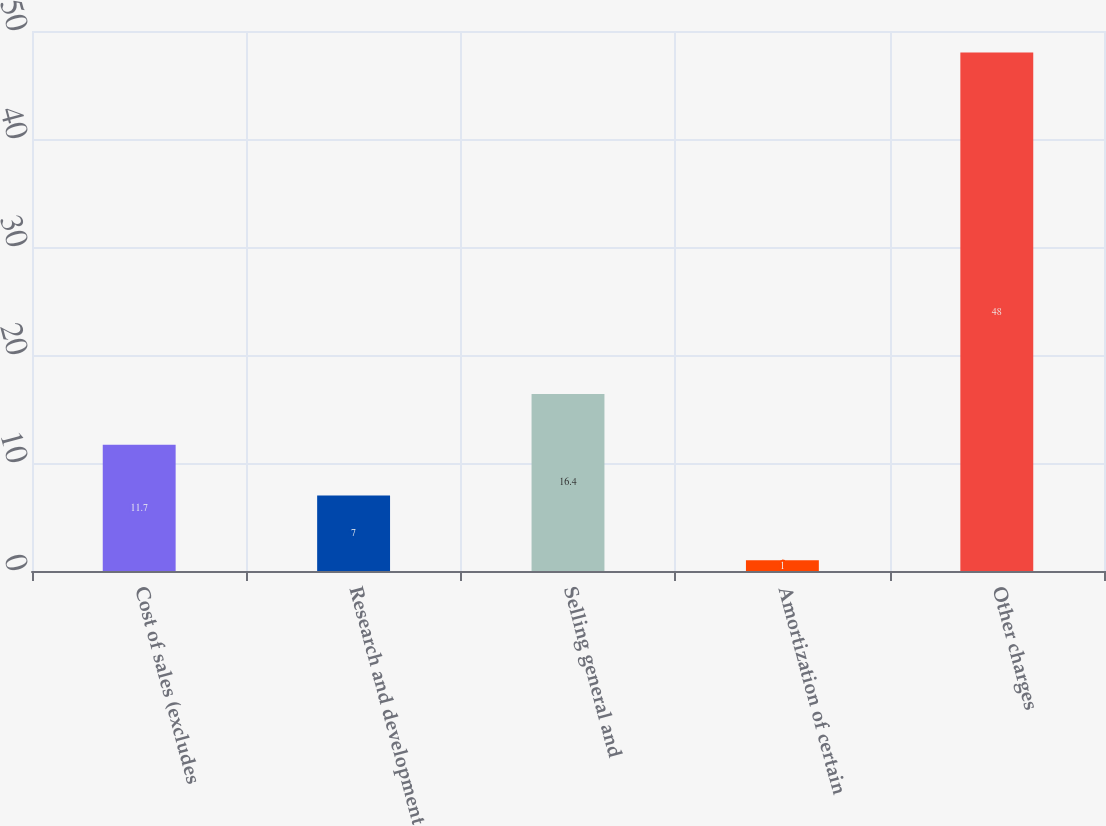<chart> <loc_0><loc_0><loc_500><loc_500><bar_chart><fcel>Cost of sales (excludes<fcel>Research and development<fcel>Selling general and<fcel>Amortization of certain<fcel>Other charges<nl><fcel>11.7<fcel>7<fcel>16.4<fcel>1<fcel>48<nl></chart> 